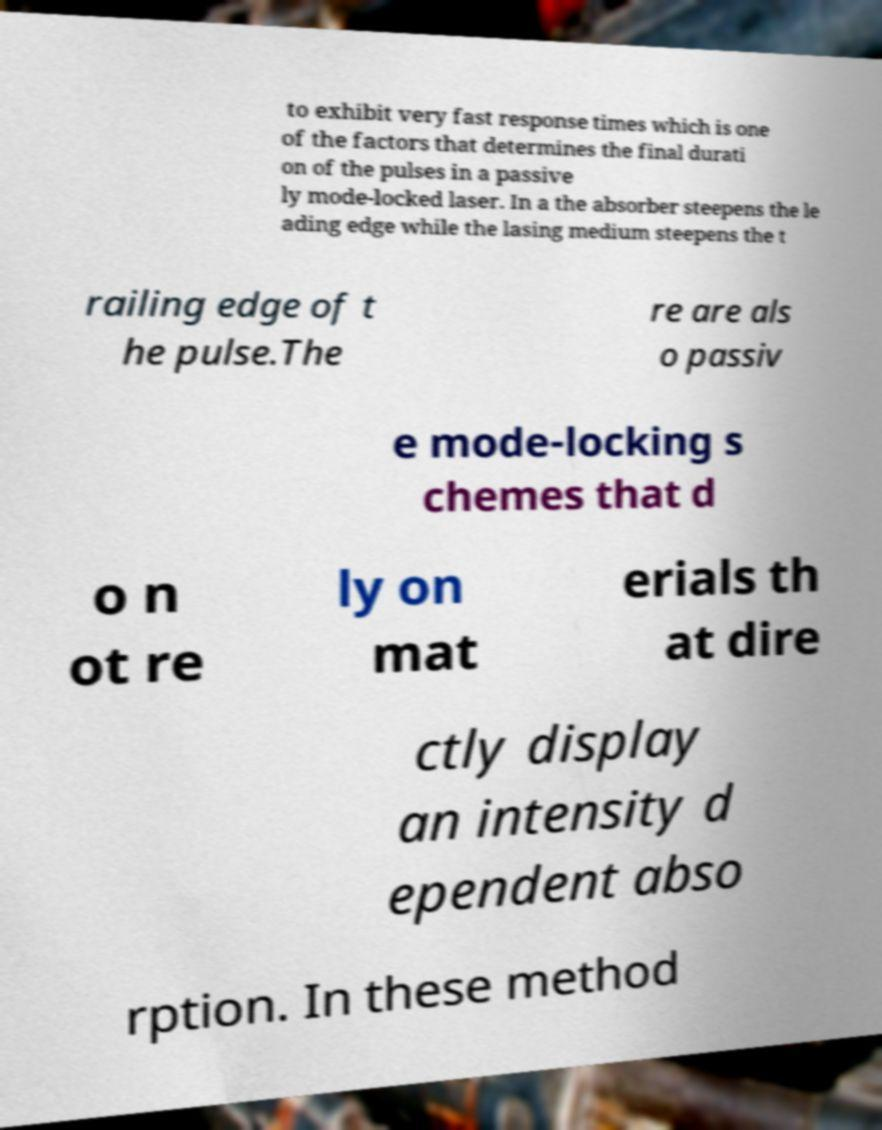There's text embedded in this image that I need extracted. Can you transcribe it verbatim? to exhibit very fast response times which is one of the factors that determines the final durati on of the pulses in a passive ly mode-locked laser. In a the absorber steepens the le ading edge while the lasing medium steepens the t railing edge of t he pulse.The re are als o passiv e mode-locking s chemes that d o n ot re ly on mat erials th at dire ctly display an intensity d ependent abso rption. In these method 